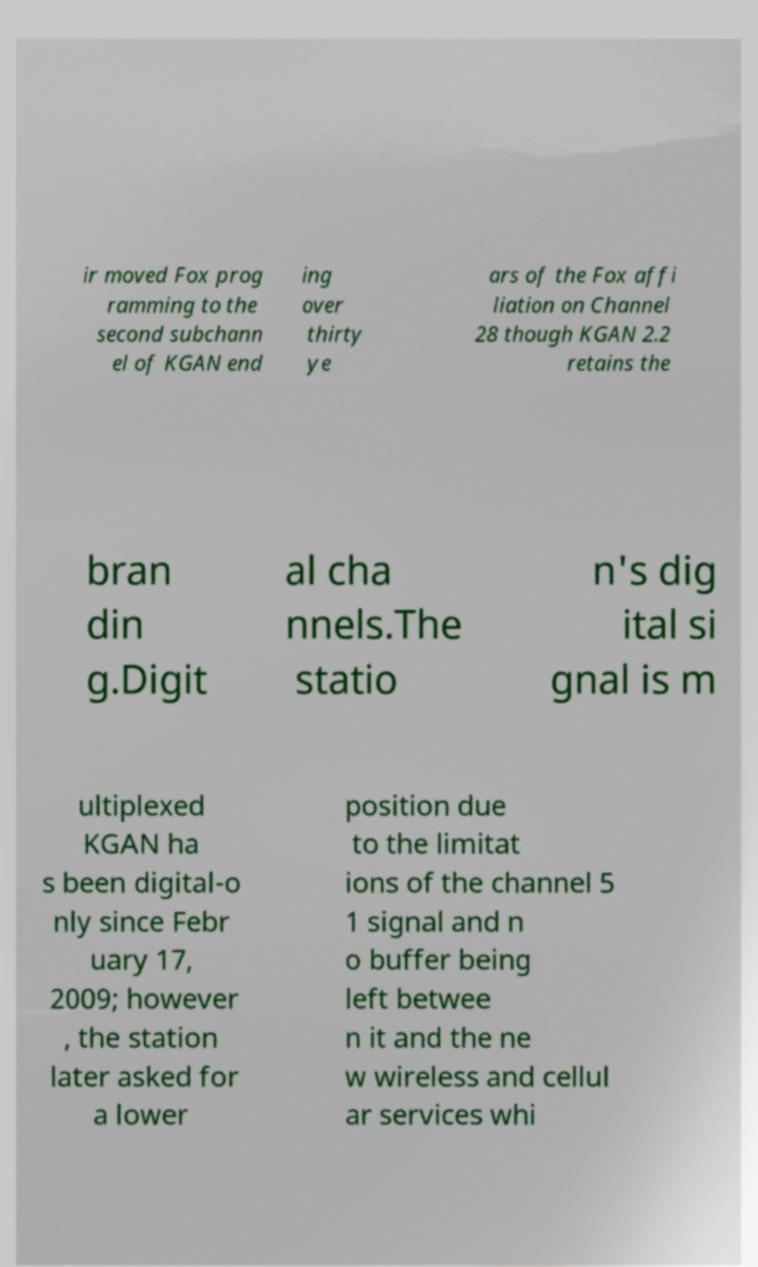Could you extract and type out the text from this image? ir moved Fox prog ramming to the second subchann el of KGAN end ing over thirty ye ars of the Fox affi liation on Channel 28 though KGAN 2.2 retains the bran din g.Digit al cha nnels.The statio n's dig ital si gnal is m ultiplexed KGAN ha s been digital-o nly since Febr uary 17, 2009; however , the station later asked for a lower position due to the limitat ions of the channel 5 1 signal and n o buffer being left betwee n it and the ne w wireless and cellul ar services whi 